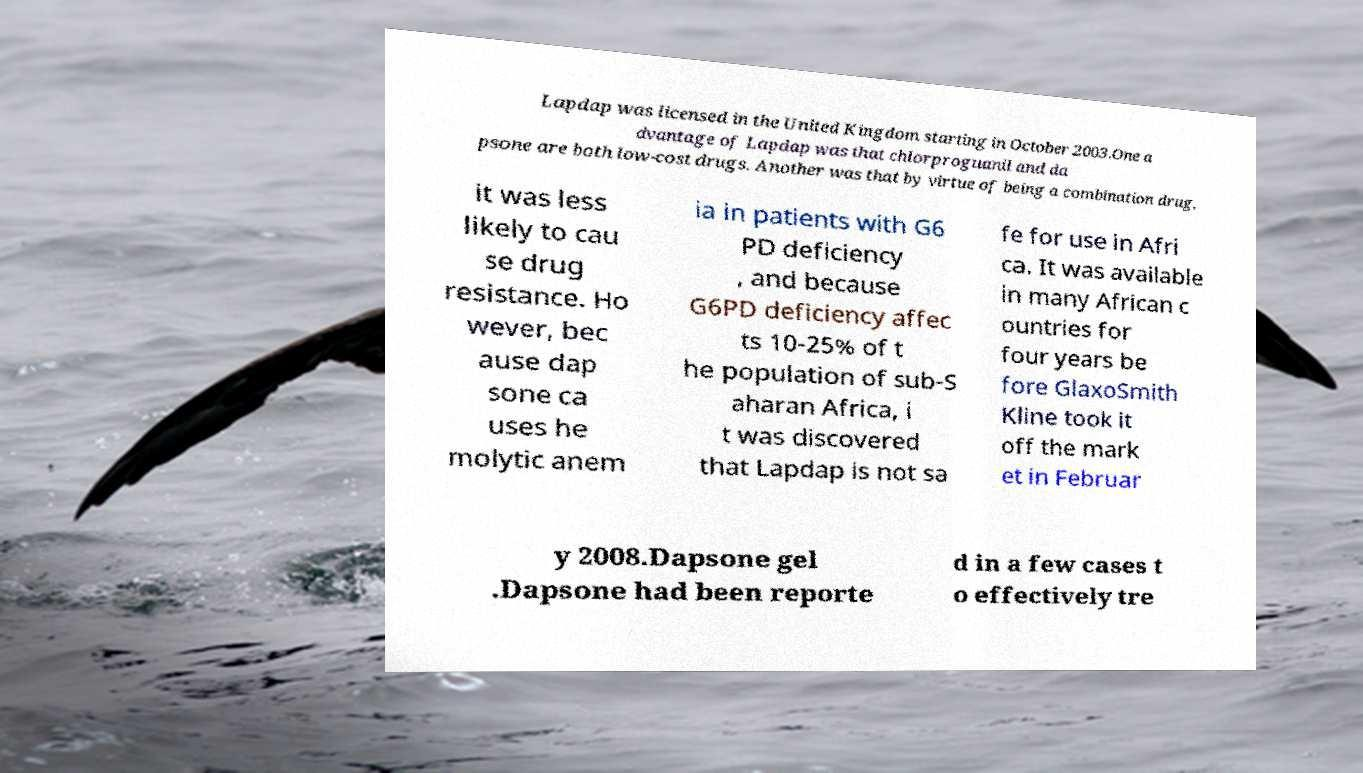Could you extract and type out the text from this image? Lapdap was licensed in the United Kingdom starting in October 2003.One a dvantage of Lapdap was that chlorproguanil and da psone are both low-cost drugs. Another was that by virtue of being a combination drug, it was less likely to cau se drug resistance. Ho wever, bec ause dap sone ca uses he molytic anem ia in patients with G6 PD deficiency , and because G6PD deficiency affec ts 10-25% of t he population of sub-S aharan Africa, i t was discovered that Lapdap is not sa fe for use in Afri ca. It was available in many African c ountries for four years be fore GlaxoSmith Kline took it off the mark et in Februar y 2008.Dapsone gel .Dapsone had been reporte d in a few cases t o effectively tre 